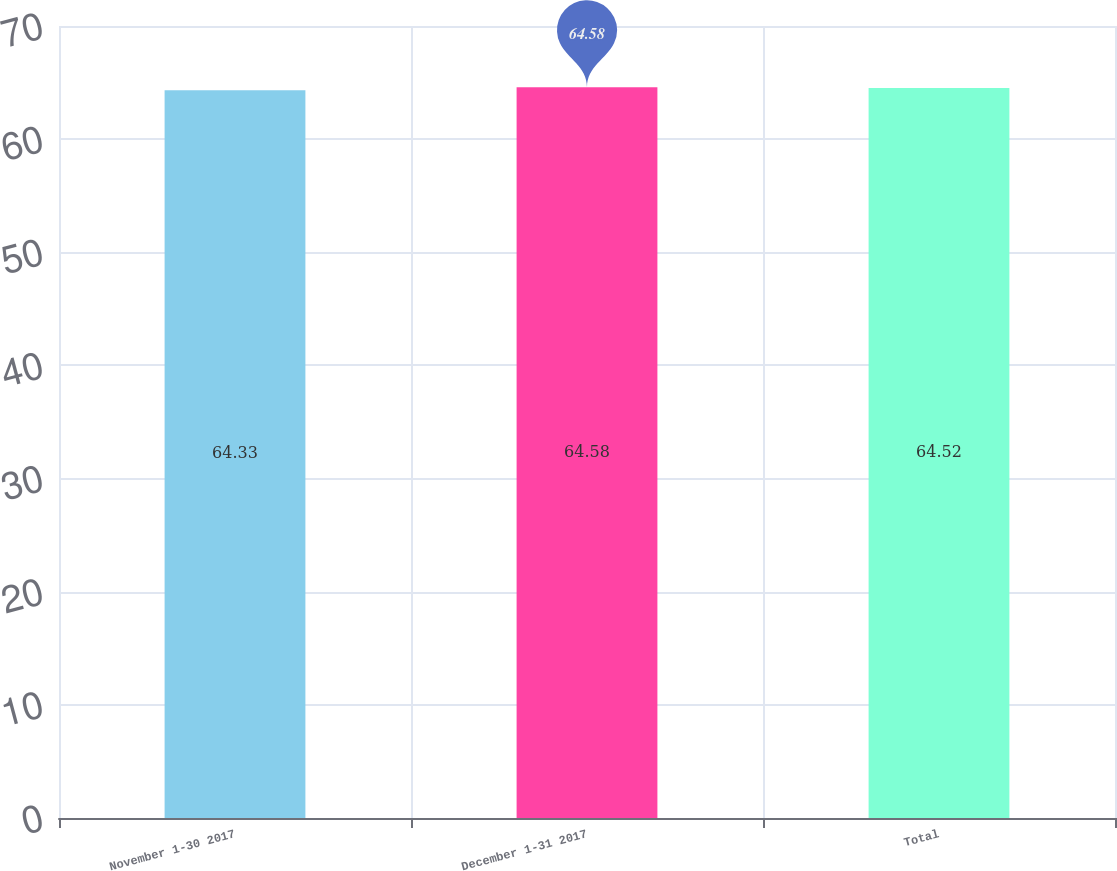Convert chart to OTSL. <chart><loc_0><loc_0><loc_500><loc_500><bar_chart><fcel>November 1-30 2017<fcel>December 1-31 2017<fcel>Total<nl><fcel>64.33<fcel>64.58<fcel>64.52<nl></chart> 